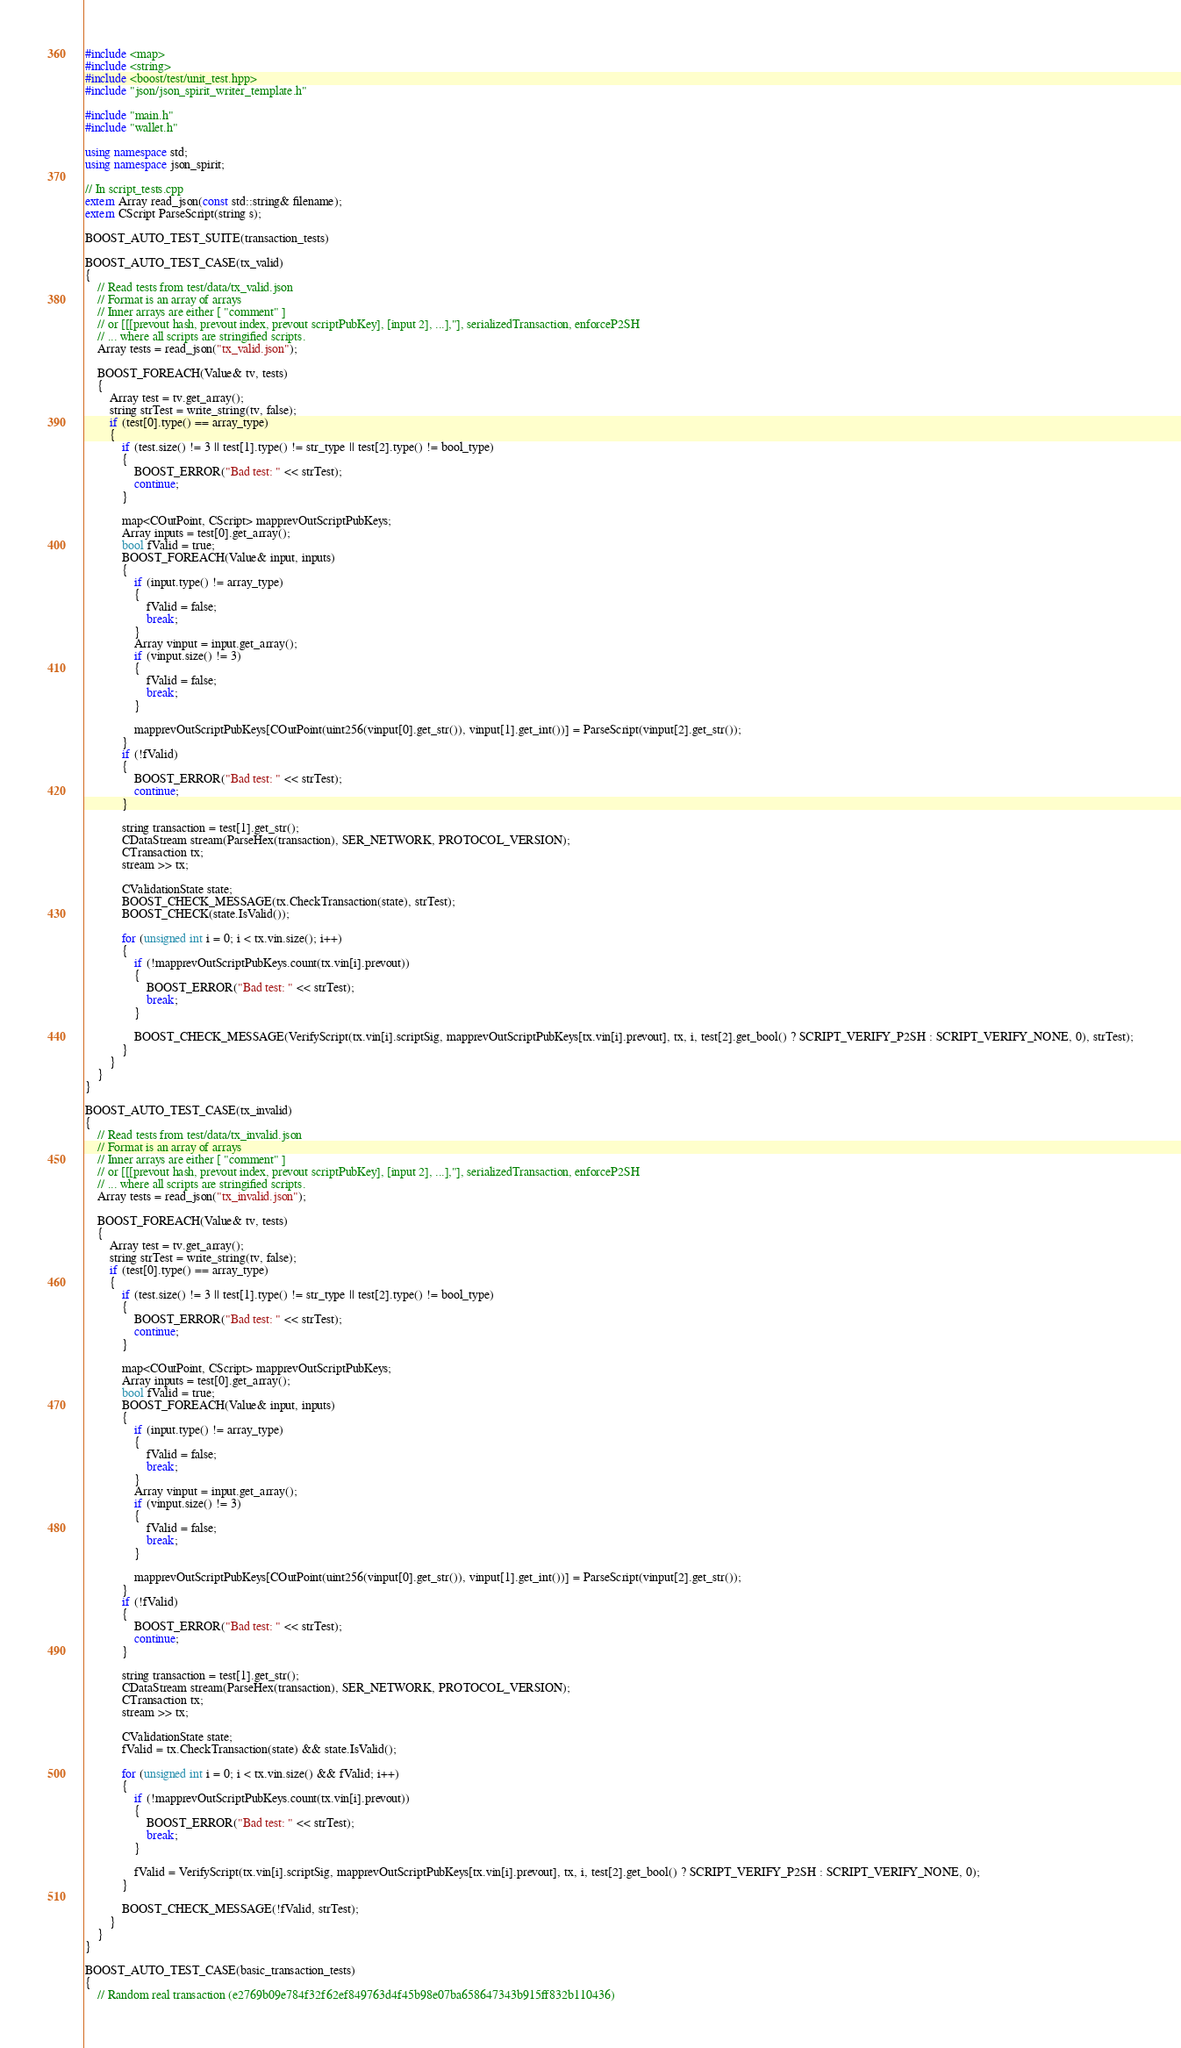<code> <loc_0><loc_0><loc_500><loc_500><_C++_>#include <map>
#include <string>
#include <boost/test/unit_test.hpp>
#include "json/json_spirit_writer_template.h"

#include "main.h"
#include "wallet.h"

using namespace std;
using namespace json_spirit;

// In script_tests.cpp
extern Array read_json(const std::string& filename);
extern CScript ParseScript(string s);

BOOST_AUTO_TEST_SUITE(transaction_tests)

BOOST_AUTO_TEST_CASE(tx_valid)
{
    // Read tests from test/data/tx_valid.json
    // Format is an array of arrays
    // Inner arrays are either [ "comment" ]
    // or [[[prevout hash, prevout index, prevout scriptPubKey], [input 2], ...],"], serializedTransaction, enforceP2SH
    // ... where all scripts are stringified scripts.
    Array tests = read_json("tx_valid.json");

    BOOST_FOREACH(Value& tv, tests)
    {
        Array test = tv.get_array();
        string strTest = write_string(tv, false);
        if (test[0].type() == array_type)
        {
            if (test.size() != 3 || test[1].type() != str_type || test[2].type() != bool_type)
            {
                BOOST_ERROR("Bad test: " << strTest);
                continue;
            }

            map<COutPoint, CScript> mapprevOutScriptPubKeys;
            Array inputs = test[0].get_array();
            bool fValid = true;
            BOOST_FOREACH(Value& input, inputs)
            {
                if (input.type() != array_type)
                {
                    fValid = false;
                    break;
                }
                Array vinput = input.get_array();
                if (vinput.size() != 3)
                {
                    fValid = false;
                    break;
                }

                mapprevOutScriptPubKeys[COutPoint(uint256(vinput[0].get_str()), vinput[1].get_int())] = ParseScript(vinput[2].get_str());
            }
            if (!fValid)
            {
                BOOST_ERROR("Bad test: " << strTest);
                continue;
            }

            string transaction = test[1].get_str();
            CDataStream stream(ParseHex(transaction), SER_NETWORK, PROTOCOL_VERSION);
            CTransaction tx;
            stream >> tx;

            CValidationState state;
            BOOST_CHECK_MESSAGE(tx.CheckTransaction(state), strTest);
            BOOST_CHECK(state.IsValid());

            for (unsigned int i = 0; i < tx.vin.size(); i++)
            {
                if (!mapprevOutScriptPubKeys.count(tx.vin[i].prevout))
                {
                    BOOST_ERROR("Bad test: " << strTest);
                    break;
                }

                BOOST_CHECK_MESSAGE(VerifyScript(tx.vin[i].scriptSig, mapprevOutScriptPubKeys[tx.vin[i].prevout], tx, i, test[2].get_bool() ? SCRIPT_VERIFY_P2SH : SCRIPT_VERIFY_NONE, 0), strTest);
            }
        }
    }
}

BOOST_AUTO_TEST_CASE(tx_invalid)
{
    // Read tests from test/data/tx_invalid.json
    // Format is an array of arrays
    // Inner arrays are either [ "comment" ]
    // or [[[prevout hash, prevout index, prevout scriptPubKey], [input 2], ...],"], serializedTransaction, enforceP2SH
    // ... where all scripts are stringified scripts.
    Array tests = read_json("tx_invalid.json");

    BOOST_FOREACH(Value& tv, tests)
    {
        Array test = tv.get_array();
        string strTest = write_string(tv, false);
        if (test[0].type() == array_type)
        {
            if (test.size() != 3 || test[1].type() != str_type || test[2].type() != bool_type)
            {
                BOOST_ERROR("Bad test: " << strTest);
                continue;
            }

            map<COutPoint, CScript> mapprevOutScriptPubKeys;
            Array inputs = test[0].get_array();
            bool fValid = true;
            BOOST_FOREACH(Value& input, inputs)
            {
                if (input.type() != array_type)
                {
                    fValid = false;
                    break;
                }
                Array vinput = input.get_array();
                if (vinput.size() != 3)
                {
                    fValid = false;
                    break;
                }

                mapprevOutScriptPubKeys[COutPoint(uint256(vinput[0].get_str()), vinput[1].get_int())] = ParseScript(vinput[2].get_str());
            }
            if (!fValid)
            {
                BOOST_ERROR("Bad test: " << strTest);
                continue;
            }

            string transaction = test[1].get_str();
            CDataStream stream(ParseHex(transaction), SER_NETWORK, PROTOCOL_VERSION);
            CTransaction tx;
            stream >> tx;

            CValidationState state;
            fValid = tx.CheckTransaction(state) && state.IsValid();

            for (unsigned int i = 0; i < tx.vin.size() && fValid; i++)
            {
                if (!mapprevOutScriptPubKeys.count(tx.vin[i].prevout))
                {
                    BOOST_ERROR("Bad test: " << strTest);
                    break;
                }

                fValid = VerifyScript(tx.vin[i].scriptSig, mapprevOutScriptPubKeys[tx.vin[i].prevout], tx, i, test[2].get_bool() ? SCRIPT_VERIFY_P2SH : SCRIPT_VERIFY_NONE, 0);
            }

            BOOST_CHECK_MESSAGE(!fValid, strTest);
        }
    }
}

BOOST_AUTO_TEST_CASE(basic_transaction_tests)
{
    // Random real transaction (e2769b09e784f32f62ef849763d4f45b98e07ba658647343b915ff832b110436)</code> 